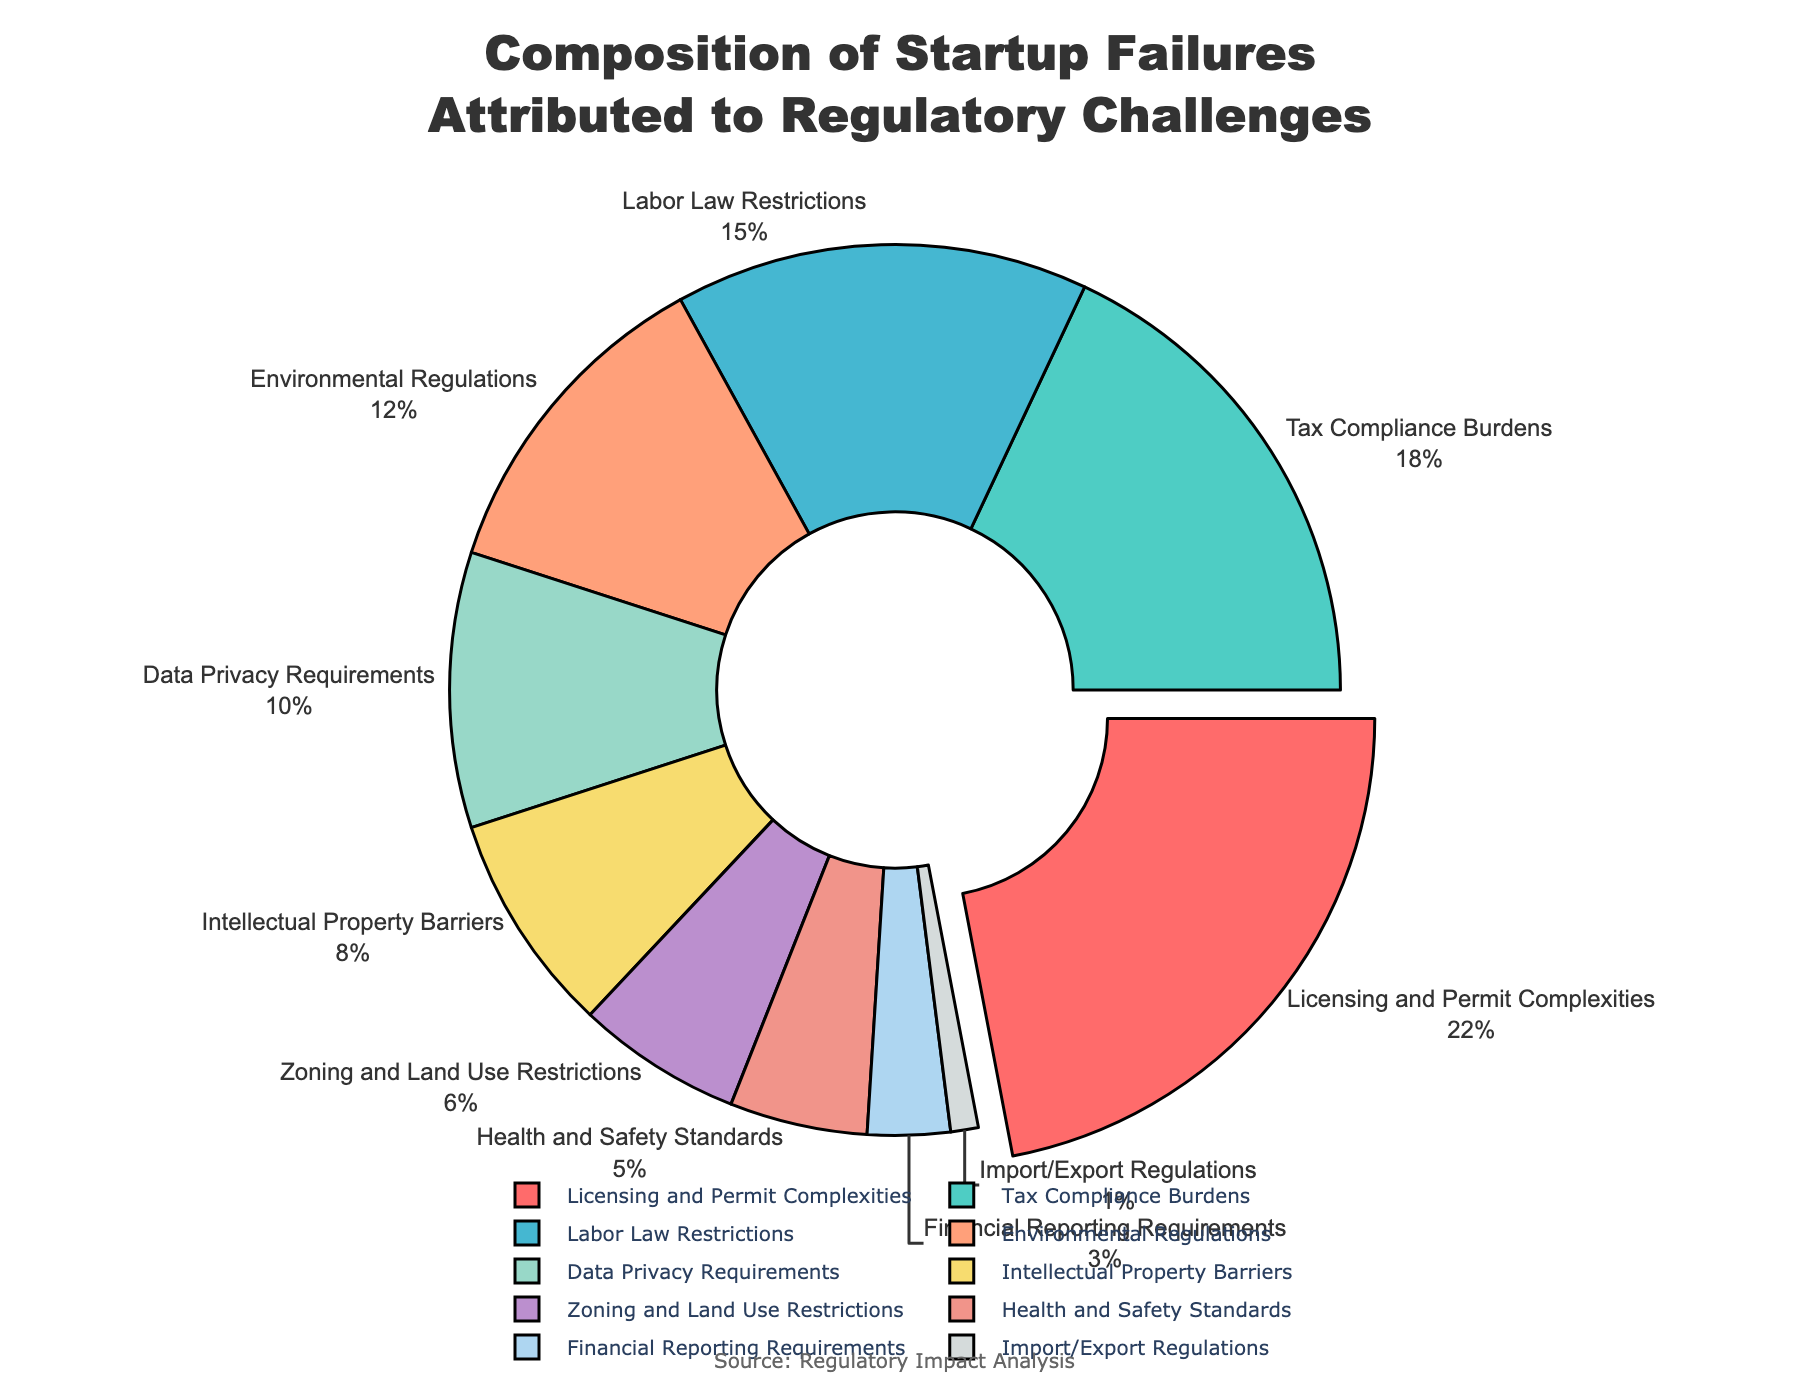What regulatory challenge accounts for the highest percentage of startup failures? The section labeled "Licensing and Permit Complexities" is visually the largest with a value of 22%, which is higher than any other section in the pie chart.
Answer: Licensing and Permit Complexities Which two regulatory challenges together make up one-third of startup failures? The challenges "Licensing and Permit Complexities" and "Tax Compliance Burdens" have percentages of 22% and 18% respectively, which add up to 40%. While 40% is very close to one-third, these two categories together exceed one-third (33.33%). The challenges "Labor Law Restrictions" and "Environmental Regulations" make up 15% and 12% respectively, adding up to 27%, which is less than one-third.
Answer: None How much higher is the percentage of startup failures attributed to "Labor Law Restrictions" compared to "Health and Safety Standards"? "Labor Law Restrictions" account for 15% while "Health and Safety Standards" account for 5%. The difference is 15% - 5% = 10%.
Answer: 10% What percentage of startup failures are attributed to the combined impact of "Intellectual Property Barriers" and "Zoning and Land Use Restrictions"? The percentages for "Intellectual Property Barriers" and "Zoning and Land Use Restrictions" are 8% and 6% respectively. Adding these, 8% + 6% = 14%.
Answer: 14% Which regulatory challenge occupies the smallest segment in the pie chart? The pie chart indicates "Import/Export Regulations" as the smallest segment with a value of 1%.
Answer: Import/Export Regulations By how much does "Tax Compliance Burdens" surpass "Data Privacy Requirements"? "Tax Compliance Burdens" make up 18%, and "Data Privacy Requirements" make up 10%. The difference between them is 18% - 10% = 8%.
Answer: 8% Calculate the average percentage of startup failures due to "Zoning and Land Use Restrictions", "Health and Safety Standards", and "Financial Reporting Requirements". The percentages are 6%, 5%, and 3% respectively. Adding them gives 6% + 5% + 3% = 14%. Dividing by three, the average is 14% / 3 ≈ 4.67%.
Answer: 4.67% Which regulatory challenges combined contributed exactly half of the startup failures? Adding up the percentages from the chart starting from the largest: "Licensing and Permit Complexities" (22%), "Tax Compliance Burdens" (18%), and "Labor Law Restrictions" (15%) gives us 22% + 18% + 15% = 55%, which exceeds half. Next, trying "Licensing and Permit Complexities" (22%) and "Tax Compliance Burdens" (18%) alone gives 40%. "Licensing and Permit Complexities" (22%) and "Labor Law Restrictions" (15%) is 37%. There isn't an exact combination that equals 50%.
Answer: None What is the median value of startup failures attributed to the regulatory challenges? Sorting the percentages in ascending order: 1%, 3%, 5%, 6%, 8%, 10%, 12%, 15%, 18%, 22%. The middle values are the 5th and 6th values: 8% and 10%. The median is the average of these two values (8% + 10%) / 2 = 9%.
Answer: 9% Which color represents the "Environmental Regulations" segment in the pie chart? The "Environmental Regulations" segment is indicated by the fourth color in the legend, which is a shade of pastel peach or light salmon.
Answer: Light salmon 